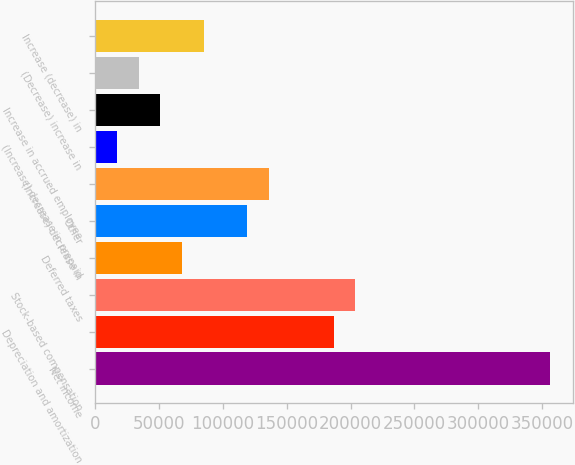<chart> <loc_0><loc_0><loc_500><loc_500><bar_chart><fcel>Net income<fcel>Depreciation and amortization<fcel>Stock-based compensation<fcel>Deferred taxes<fcel>Other<fcel>(Increase) decrease in<fcel>(Increase) decrease in prepaid<fcel>Increase in accrued employee<fcel>(Decrease) increase in<fcel>Increase (decrease) in<nl><fcel>356155<fcel>186578<fcel>203535<fcel>67873.8<fcel>118747<fcel>135705<fcel>17000.7<fcel>50916.1<fcel>33958.4<fcel>84831.5<nl></chart> 